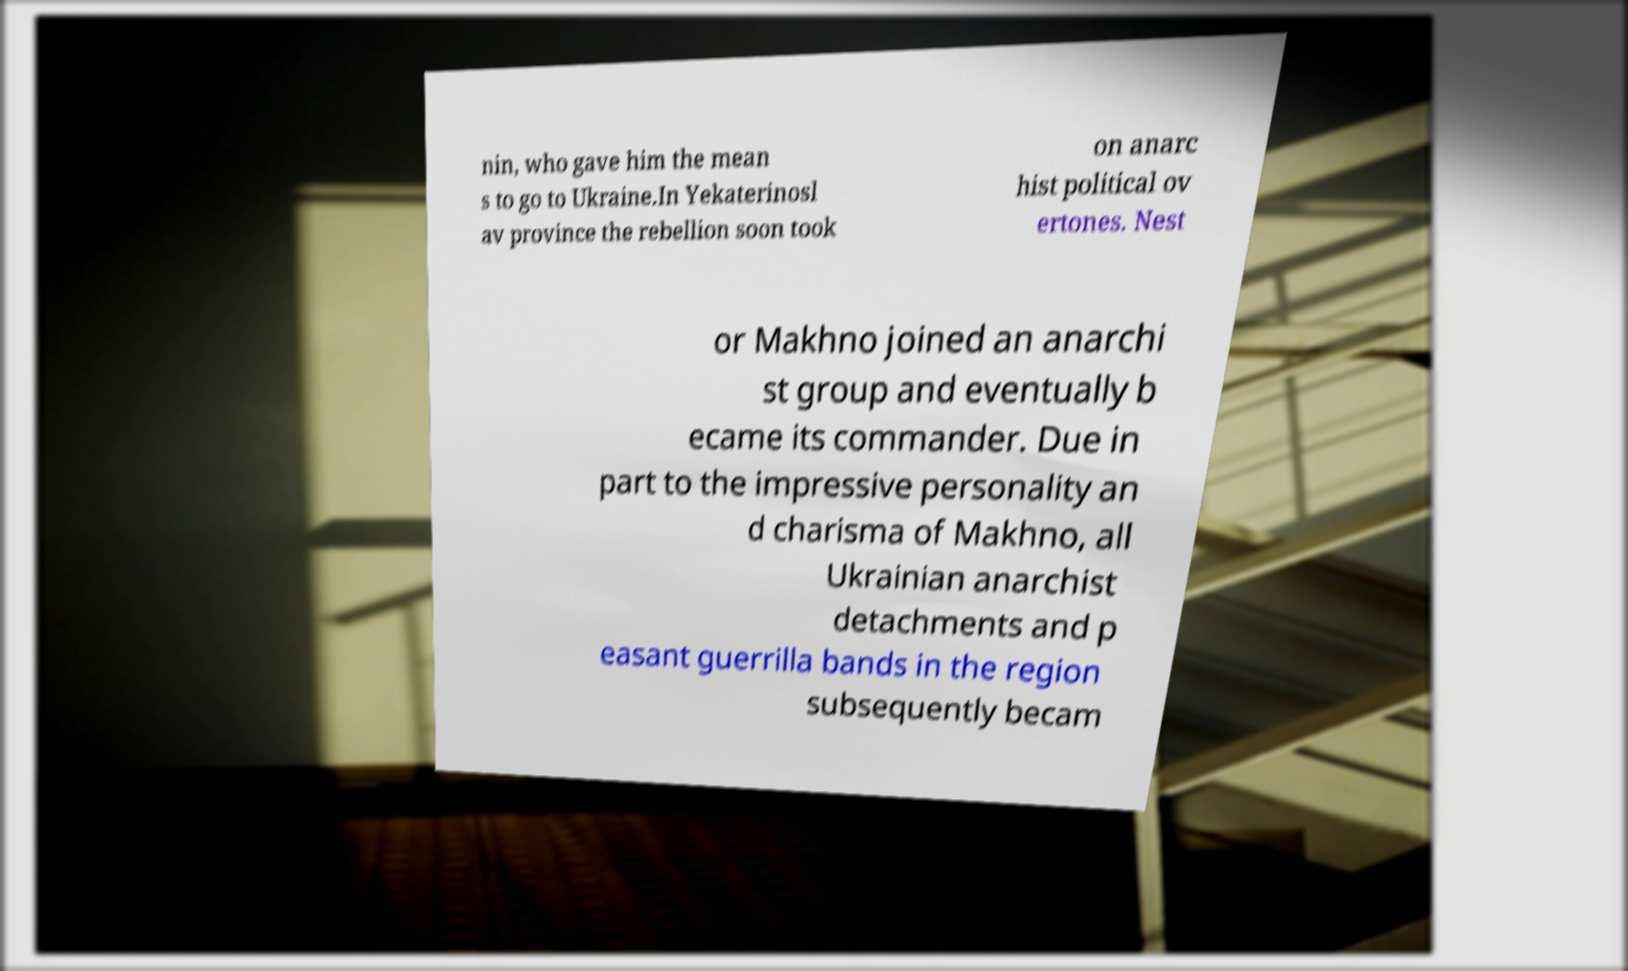Please identify and transcribe the text found in this image. nin, who gave him the mean s to go to Ukraine.In Yekaterinosl av province the rebellion soon took on anarc hist political ov ertones. Nest or Makhno joined an anarchi st group and eventually b ecame its commander. Due in part to the impressive personality an d charisma of Makhno, all Ukrainian anarchist detachments and p easant guerrilla bands in the region subsequently becam 